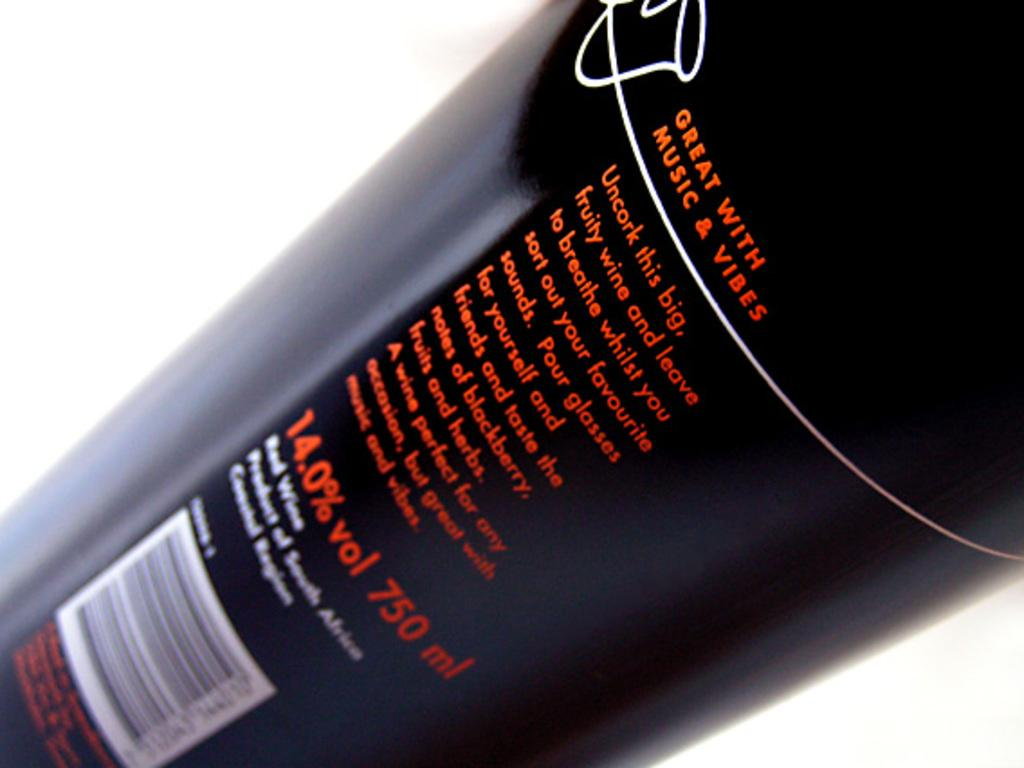<image>
Relay a brief, clear account of the picture shown. The back of a wine bottle that is great with music &vibes. 